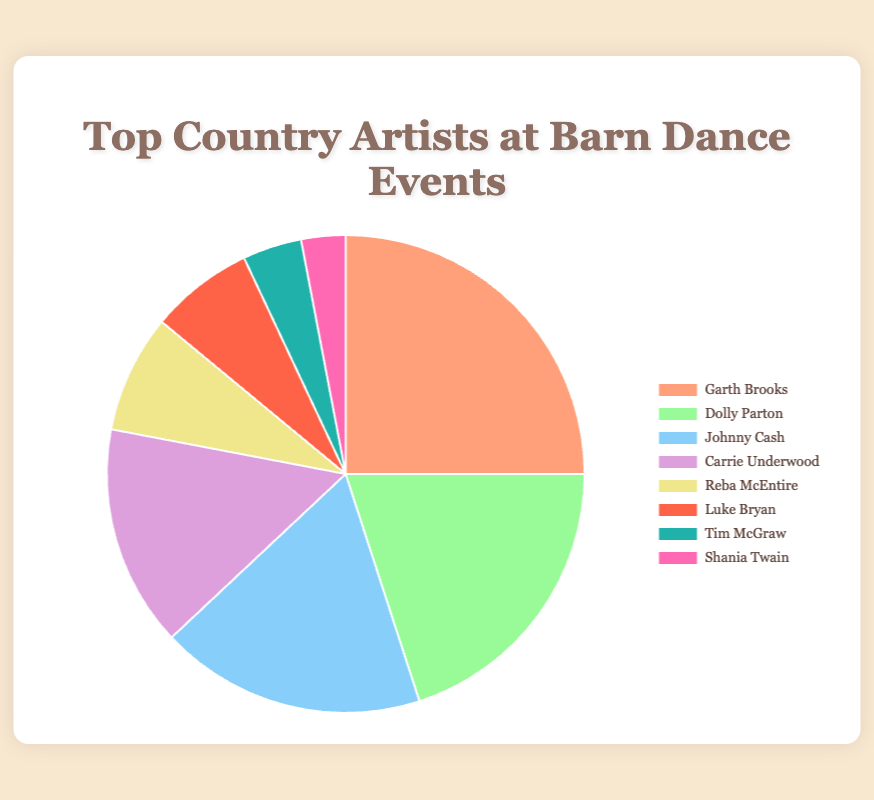What percentage of requests go to the top two most requested artists combined? Garth Brooks and Dolly Parton have request percentages of 25% and 20% respectively. Adding these together gives 25% + 20% = 45%.
Answer: 45% Visualize the share of the pie chart for Carrie Underwood. What color represents her segment? The chart labels Carrie Underwood's segment with a distinct purple color, indicating that her section is shaded in purple.
Answer: Purple Which artist's requests sum up to less than 15%? Reba McEntire (8%), Luke Bryan (7%), Tim McGraw (4%), and Shania Twain (3%) all have request percentages that, individually, are less than 15%.
Answer: Reba McEntire, Luke Bryan, Tim McGraw, Shania Twain Compare the requests for Johnny Cash and Carrie Underwood. Who has more, and by what percentage? Johnny Cash is at 18%, while Carrie Underwood is at 15%. The difference is 18% - 15% = 3%. Johnny Cash has 3% more requests than Carrie Underwood.
Answer: Johnny Cash by 3% Sum the percentage of requests for Dolly Parton, Reba McEntire, and Luke Bryan. Dolly Parton has 20%, Reba McEntire has 8%, and Luke Bryan has 7%. The sum is 20% + 8% + 7% = 35%.
Answer: 35% Is the percentage of requests for Tim McGraw greater than those for Shania Twain? Tim McGraw has 4% of the requests, and Shania Twain has 3%. Since 4% is greater than 3%, Tim McGraw has a higher percentage.
Answer: Yes What is the combined percentage of requests for artists other than Garth Brooks and Johnny Cash? Excluding Garth Brooks (25%) and Johnny Cash (18%), the combined percentage for remaining artists is: 20% (Dolly Parton) + 15% (Carrie Underwood) + 8% (Reba McEntire) + 7% (Luke Bryan) + 4% (Tim McGraw) + 3% (Shania Twain) = 57%.
Answer: 57% Identify the artist with the second least requested percentage and state the percentage. Shania Twain has 3%, the least. The second least is Tim McGraw, with 4%.
Answer: Tim McGraw, 4% What is the percentage difference between requests for the top requested artist and the least requested artist? Garth Brooks, the top requested artist, has 25%. Shania Twain, the least requested, has 3%. The difference is 25% - 3% = 22%.
Answer: 22% Based on the chart, how many artists have a request percentage in double digits? By observing the chart, Garth Brooks (25%), Dolly Parton (20%), Johnny Cash (18%), and Carrie Underwood (15%) all have double-digit percentages.
Answer: 4 